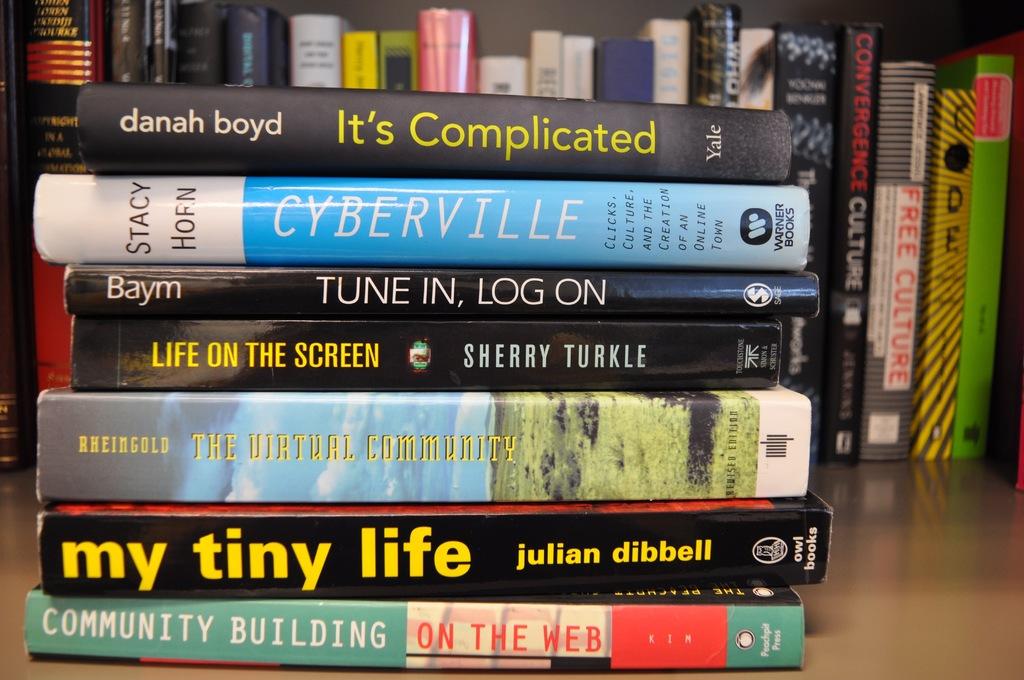What is the title of the 6th book?
Ensure brevity in your answer.  My tiny life. Who is the author of the 1st book?
Make the answer very short. Danah boyd. 